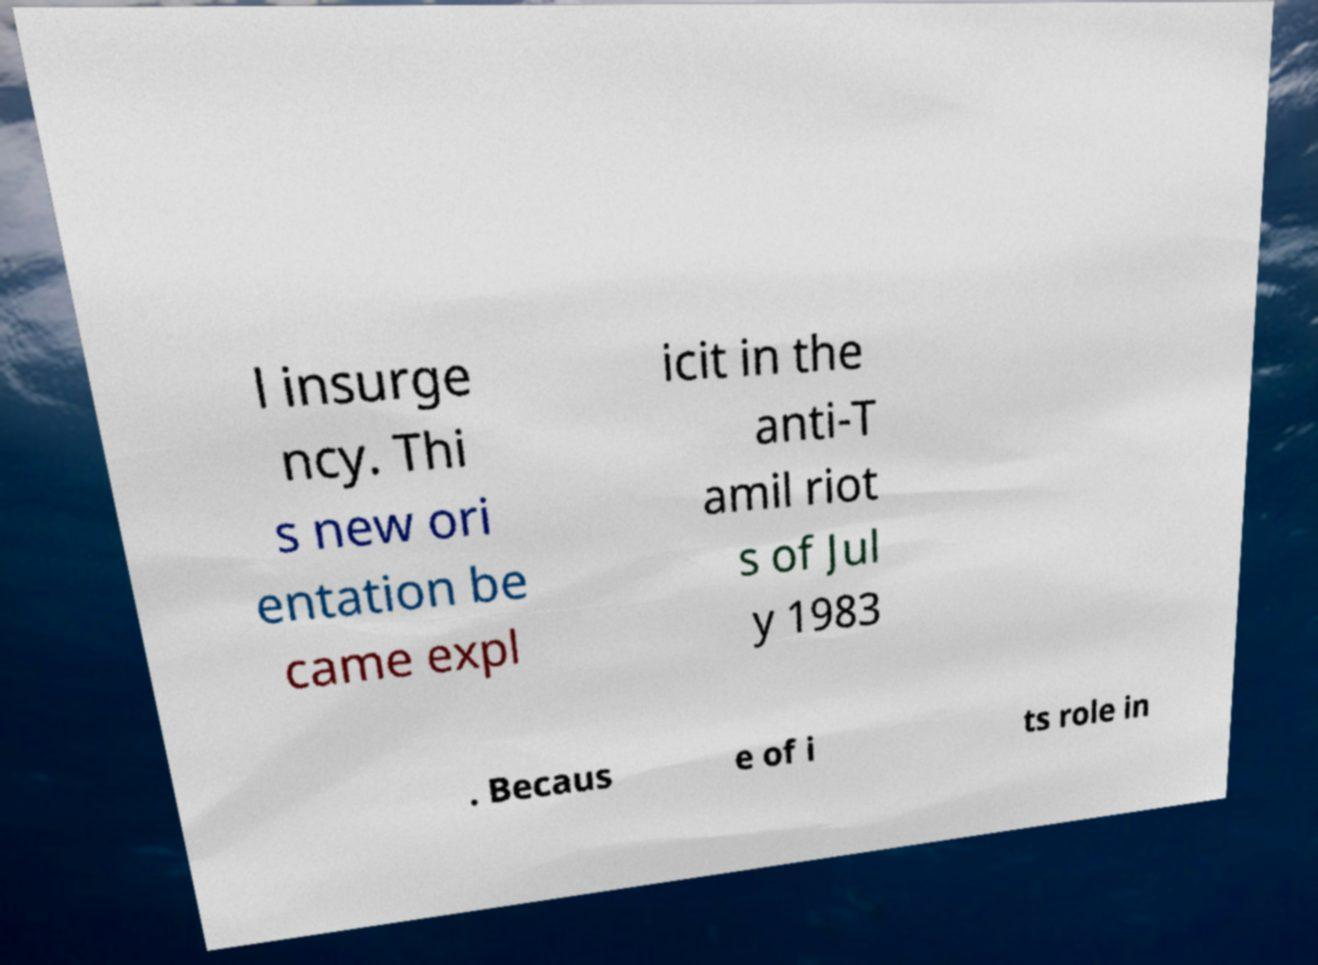Please identify and transcribe the text found in this image. l insurge ncy. Thi s new ori entation be came expl icit in the anti-T amil riot s of Jul y 1983 . Becaus e of i ts role in 